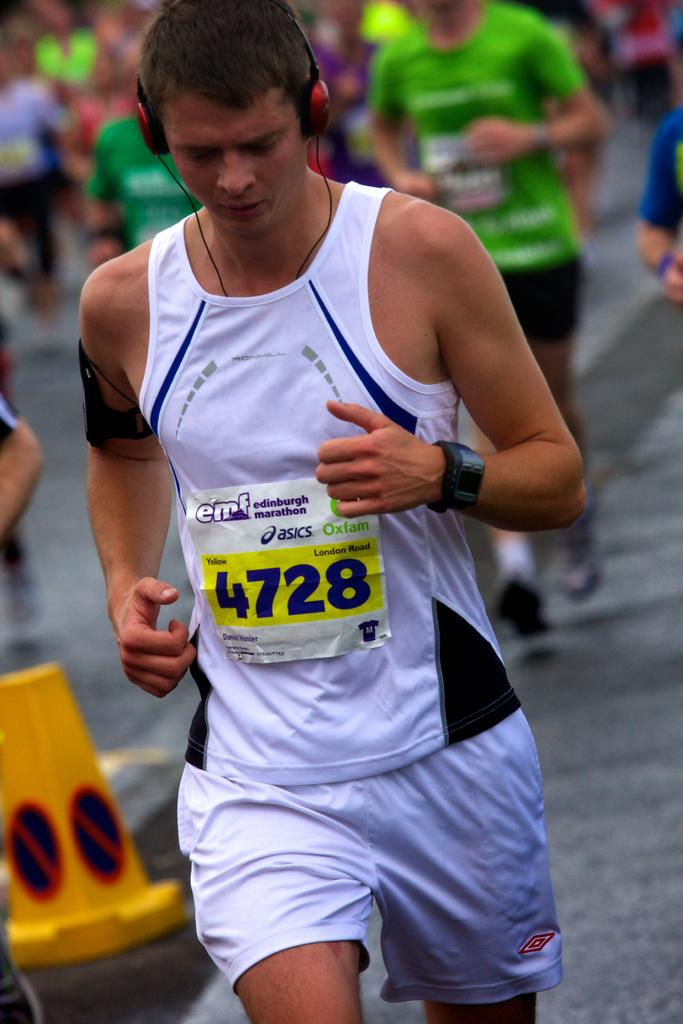<image>
Create a compact narrative representing the image presented. a person wearing a 4728 item on their shirt 